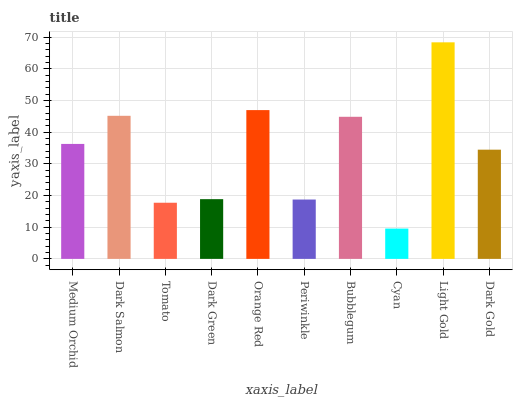Is Cyan the minimum?
Answer yes or no. Yes. Is Light Gold the maximum?
Answer yes or no. Yes. Is Dark Salmon the minimum?
Answer yes or no. No. Is Dark Salmon the maximum?
Answer yes or no. No. Is Dark Salmon greater than Medium Orchid?
Answer yes or no. Yes. Is Medium Orchid less than Dark Salmon?
Answer yes or no. Yes. Is Medium Orchid greater than Dark Salmon?
Answer yes or no. No. Is Dark Salmon less than Medium Orchid?
Answer yes or no. No. Is Medium Orchid the high median?
Answer yes or no. Yes. Is Dark Gold the low median?
Answer yes or no. Yes. Is Periwinkle the high median?
Answer yes or no. No. Is Light Gold the low median?
Answer yes or no. No. 